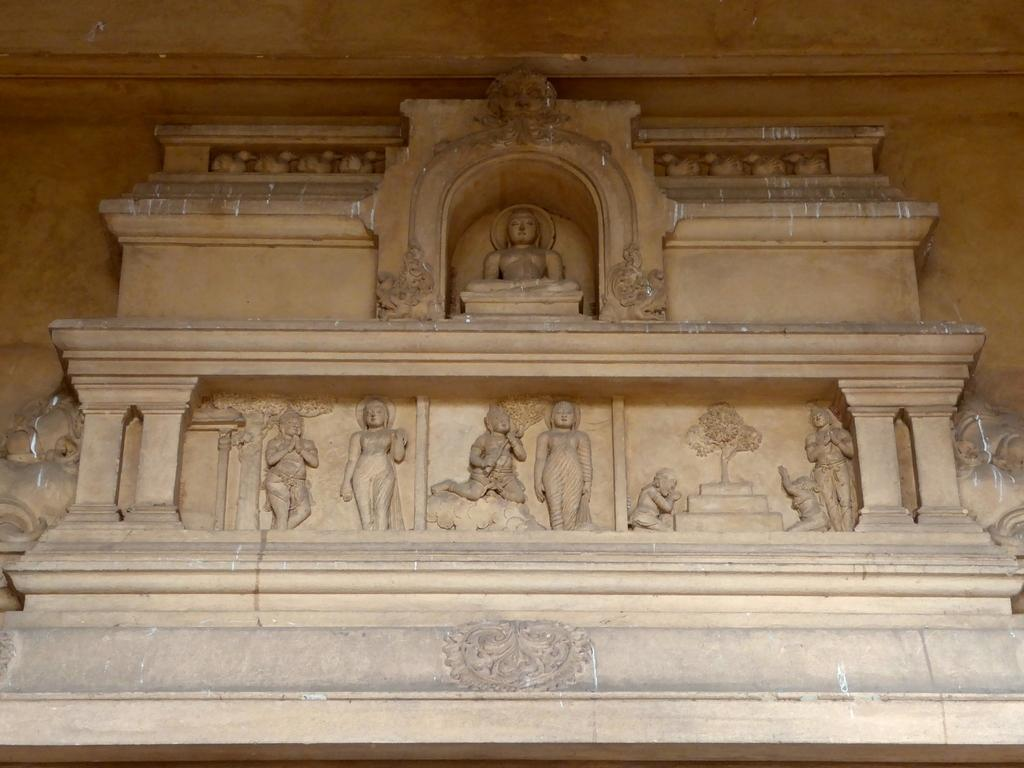What type of art is present in the image? There are sculptures in the image. Where are the sculptures located in relation to the viewer? The sculptures are in front. What can be seen in the background of the image? There is a wall in the background of the image. What type of cart is being used to transport the lettuce in the image? There is no cart or lettuce present in the image; it features sculptures and a wall in the background. Can you tell me how many toads are sitting on the sculptures in the image? There are no toads present in the image; it only features sculptures and a wall in the background. 